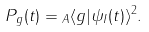<formula> <loc_0><loc_0><loc_500><loc_500>P _ { g } ( t ) = \| _ { A } \langle g | \psi _ { I } ( t ) \rangle \| ^ { 2 } .</formula> 